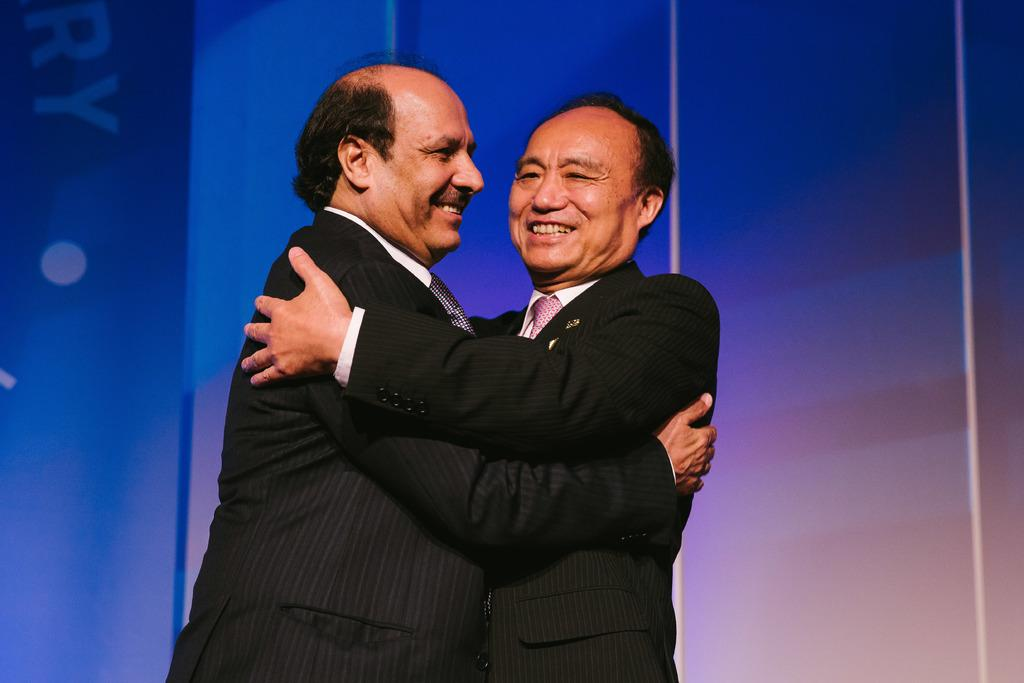How many people are in the image? There are two men in the image. What are the two men doing in the image? The two men are hugging each other. What color is the background of the image? The background of the image is blue. What type of bat can be seen flying in the image? There is no bat present in the image; it features two men hugging each other with a blue background. 